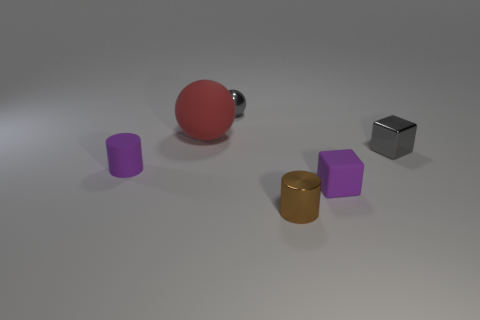Does the small ball have the same color as the tiny metal cube?
Your answer should be compact. Yes. What is the shape of the thing that is both to the left of the tiny sphere and in front of the big red object?
Your answer should be very brief. Cylinder. Is there a small thing that has the same color as the small ball?
Keep it short and to the point. Yes. What is the color of the tiny cube behind the cylinder to the left of the big red matte object?
Make the answer very short. Gray. What is the size of the purple object on the left side of the gray object to the left of the small rubber thing that is right of the large red thing?
Your answer should be very brief. Small. Are the tiny brown thing and the tiny gray thing that is right of the small matte cube made of the same material?
Offer a terse response. Yes. There is a gray sphere that is the same material as the gray cube; what size is it?
Your answer should be compact. Small. Are there any other shiny objects of the same shape as the tiny brown metallic object?
Keep it short and to the point. No. How many objects are either small objects that are behind the tiny gray shiny cube or tiny gray metal cylinders?
Keep it short and to the point. 1. What is the size of the metal thing that is the same color as the tiny metal cube?
Your answer should be compact. Small. 